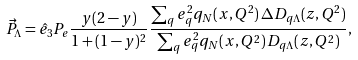<formula> <loc_0><loc_0><loc_500><loc_500>\vec { P } _ { \Lambda } = \hat { e } _ { 3 } P _ { e } \frac { y ( 2 - y ) } { 1 + ( 1 - y ) ^ { 2 } } \frac { \sum _ { q } e _ { q } ^ { 2 } q _ { N } ( x , Q ^ { 2 } ) \, \Delta D _ { q \Lambda } ( z , Q ^ { 2 } ) } { \sum _ { q } e ^ { 2 } _ { q } q _ { N } ( x , Q ^ { 2 } ) \, D _ { q \Lambda } ( z , Q ^ { 2 } ) } ,</formula> 